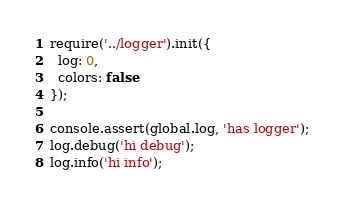Convert code to text. <code><loc_0><loc_0><loc_500><loc_500><_JavaScript_>require('../logger').init({
  log: 0,
  colors: false
});

console.assert(global.log, 'has logger');
log.debug('hi debug');
log.info('hi info');
</code> 